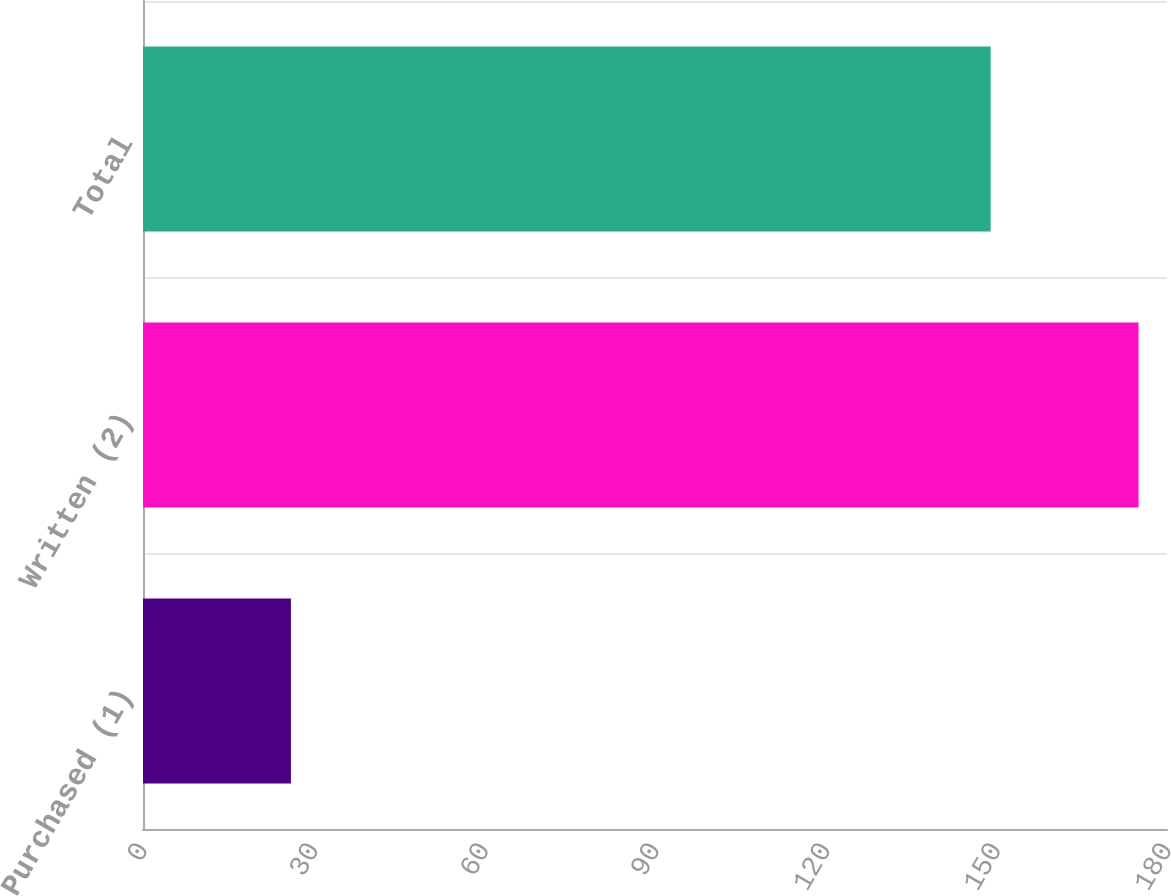<chart> <loc_0><loc_0><loc_500><loc_500><bar_chart><fcel>Purchased (1)<fcel>Written (2)<fcel>Total<nl><fcel>26<fcel>175<fcel>149<nl></chart> 